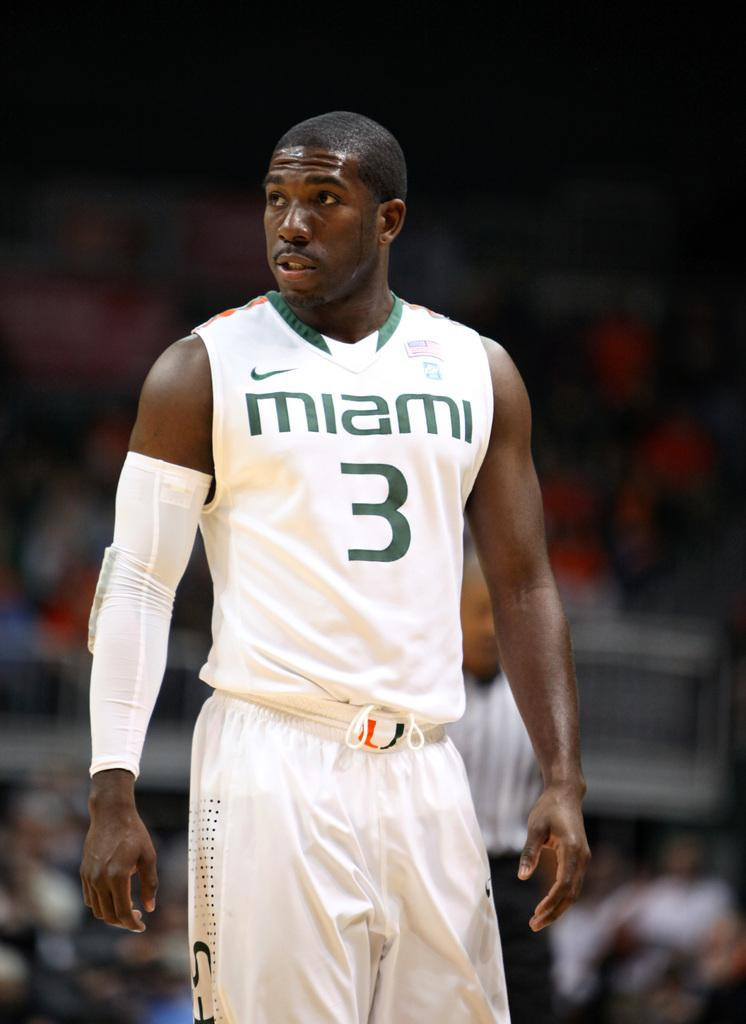What is the man in the image wearing on his upper body? The man is wearing a T-shirt. What is the man wearing on his wrist in the image? The man is wearing a hand band. What is the man wearing on his lower body in the image? The man is wearing trousers. How many people are standing in the image? There are two people standing in the image. Can you describe the background of the image? The background of the image appears blurry. What type of writer is visible in the image? There is no writer present in the image. Is the man in the image sinking into quicksand? There is no quicksand present in the image, and the man is standing on solid ground. 